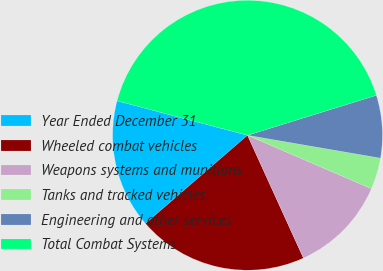<chart> <loc_0><loc_0><loc_500><loc_500><pie_chart><fcel>Year Ended December 31<fcel>Wheeled combat vehicles<fcel>Weapons systems and munitions<fcel>Tanks and tracked vehicles<fcel>Engineering and other services<fcel>Total Combat Systems<nl><fcel>15.46%<fcel>20.45%<fcel>11.72%<fcel>3.77%<fcel>7.5%<fcel>41.1%<nl></chart> 